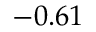Convert formula to latex. <formula><loc_0><loc_0><loc_500><loc_500>- 0 . 6 1</formula> 